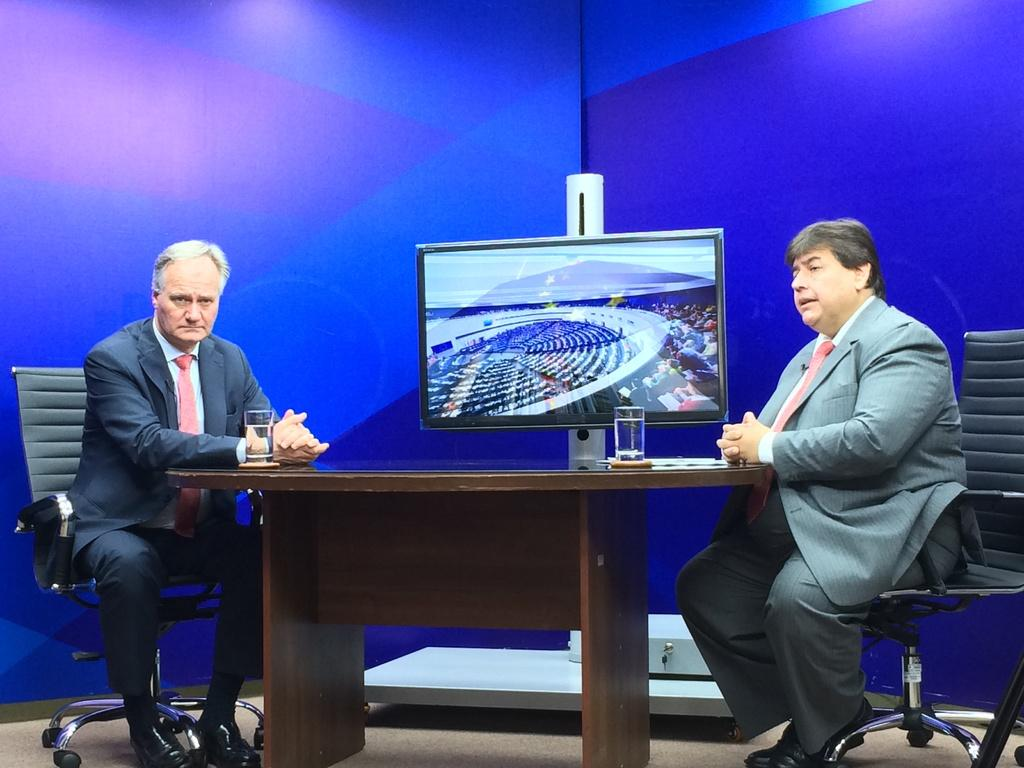How many people are in the image? There are two men in the image. What are the men doing in the image? The men are sitting in chairs. Where are the chairs located in relation to the table? The chairs are on either side of the table. What objects can be seen on the table? There are glasses and a television on the table. What color is the wall visible in the background? The wall in the background is blue. Can you tell me how many notebooks are on the table in the image? There are no notebooks present on the table in the image. 